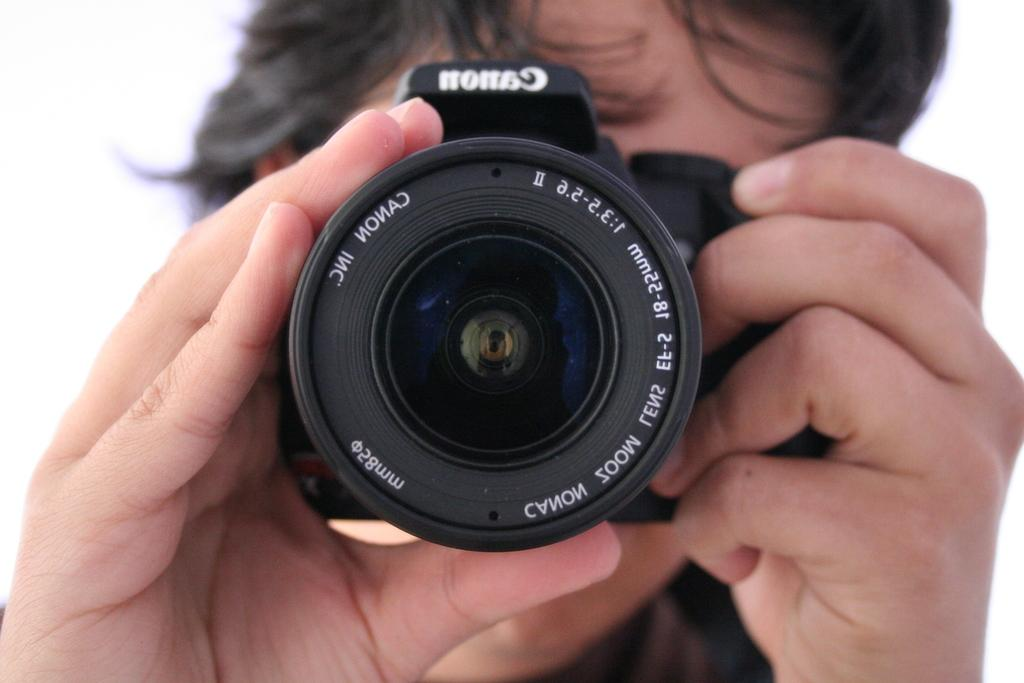<image>
Write a terse but informative summary of the picture. A photographer adjusts the zoom lens of a Canon camera. 